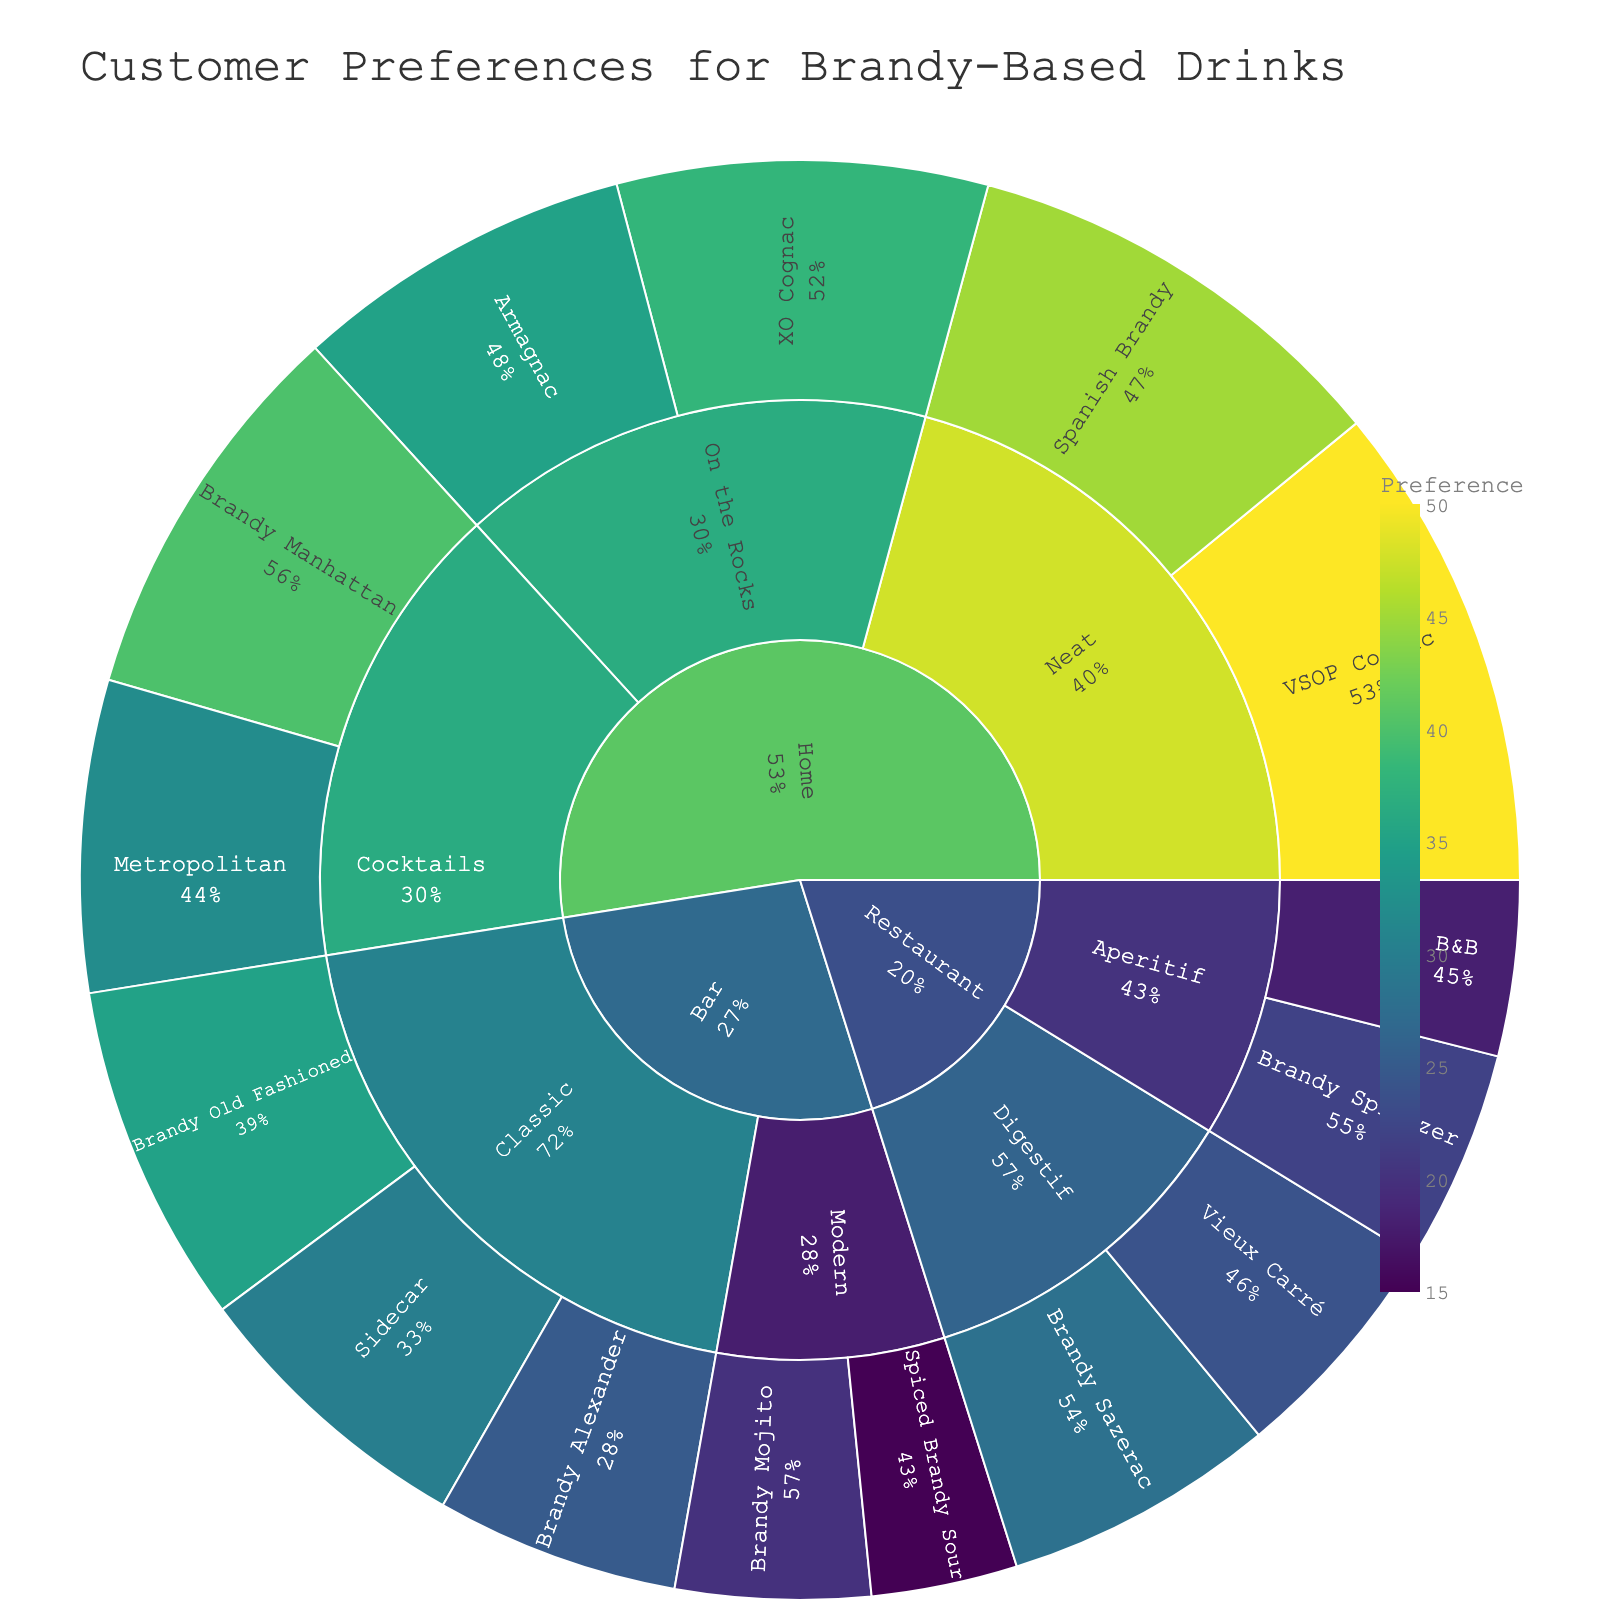What is the title of the sunburst plot? The title of the figure is typically found at the top and usually larger than other text elements. In this case, it is "Customer Preferences for Brandy-Based Drinks".
Answer: Customer Preferences for Brandy-Based Drinks Which subcategory has the highest preference in home consumption? Look at the "Home" category, then compare the preferences of "Cocktails", "Neat", and "On the Rocks". "Neat" (VSOP Cognac and Spanish Brandy) has higher values compared to others.
Answer: Neat How does the preference for Sidecar in bars compare to Brandy Old Fashioned in bars? Look at the preferences listed under the "Classic" subcategory in "Bar". Sidecar has a preference of 30, while Brandy Old Fashioned is 35. Brandy Old Fashioned is more preferred.
Answer: Brandy Old Fashioned What is the combined preference for Brandy Sazerac and Vieux Carré in restaurants? Identify the preferences for Brandy Sazerac (28) and Vieux Carré (24) under the "Digestif" subcategory in "Restaurant", then sum them. 28 + 24 = 52.
Answer: 52 What is the percentage preference of Brandy Manhattan in home consumption compared to the total home preferences? First, calculate the total preferences for all home drinks: 40 (Brandy Manhattan) + 32 (Metropolitan) + 50 (VSOP Cognac) + 45 (Spanish Brandy) + 38 (XO Cognac) + 35 (Armagnac) = 240. Then, compute the percentage of Brandy Manhattan: (40 / 240) * 100 = 16.67%.
Answer: 16.67% Is the preference for cocktails at home higher than the preference for classic brandy drinks in bars? Compare the total for "Cocktails" in "Home" (40 + 32 = 72) to the total for "Classic" in "Bar" (30 + 25 + 35 = 90). The home cocktails preference (72) is lower than bar classic drinks (90).
Answer: No Which drink under the bar category has the least preference? Compare the preferences under both "Classic" and "Modern" subcategories in "Bar". The one with the smallest value is Spiced Brandy Sour with 15.
Answer: Spiced Brandy Sour Between VSOP Cognac and XO Cognac, which has higher home consumption preference and by how much? Compare the preferences of VSOP Cognac (50) and XO Cognac (38) under "Neat" and "On the Rocks" respectively in "Home". VSOP Cognac is preferred more by (50 - 38 = 12).
Answer: VSOP Cognac, by 12 Which setting (bar, restaurant, or home) has the highest overall preference for brandy-based drinks? Sum the preferences for each setting: Bar (30 + 25 + 35 + 20 + 15 = 125), Restaurant (18 + 22 + 28 + 24 = 92), Home (40 + 32 + 50 + 45 + 38 + 35 = 240). The home setting has the highest preference.
Answer: Home 